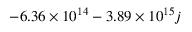<formula> <loc_0><loc_0><loc_500><loc_500>- 6 . 3 6 \times 1 0 ^ { 1 4 } - 3 . 8 9 \times 1 0 ^ { 1 5 } j</formula> 